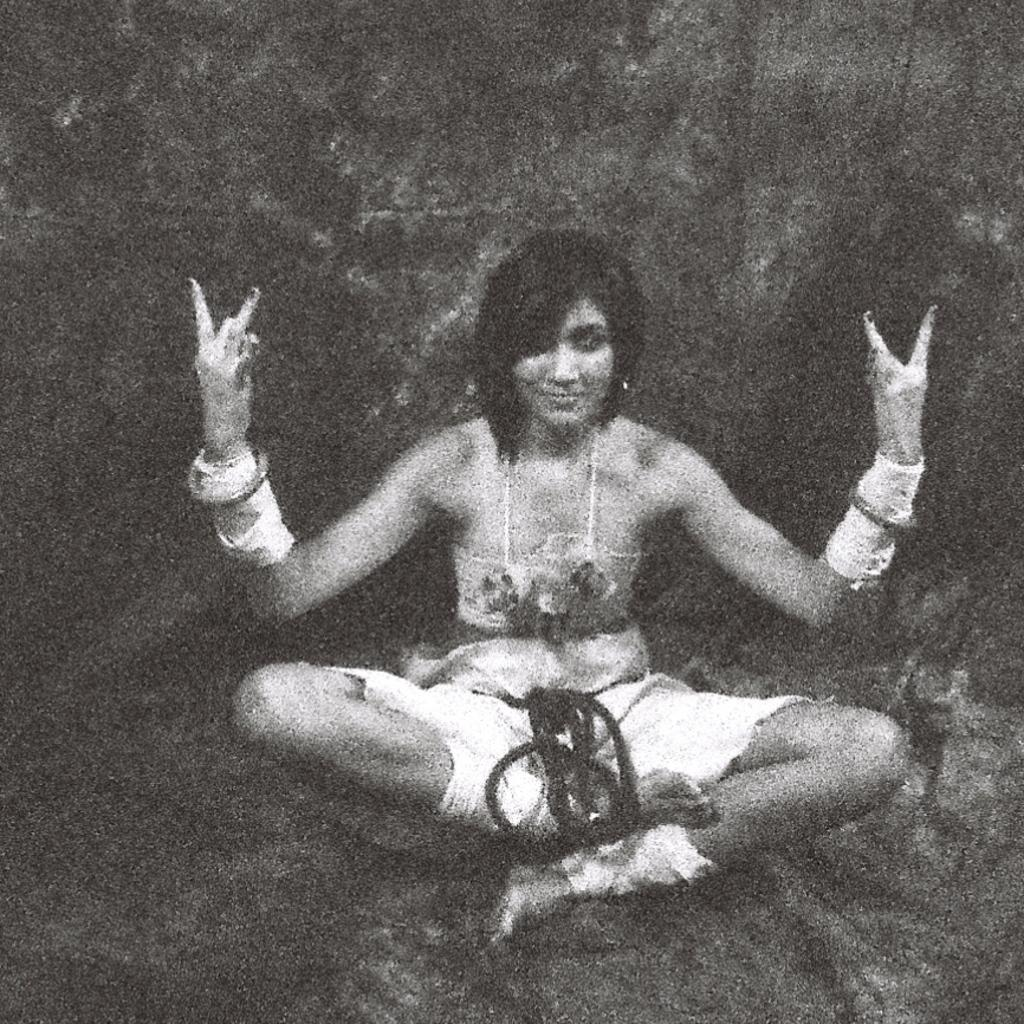What is the color scheme of the image? The image is black and white. Who is present in the image? There is a woman in the image. What is the woman doing in the image? The woman is sitting on the ground. What type of furniture is the woman using to sit in the image? The image is black and white and does not show any furniture; the woman is sitting on the ground. What substance is the woman holding in the image? There is no substance visible in the image; the woman is simply sitting on the ground. 